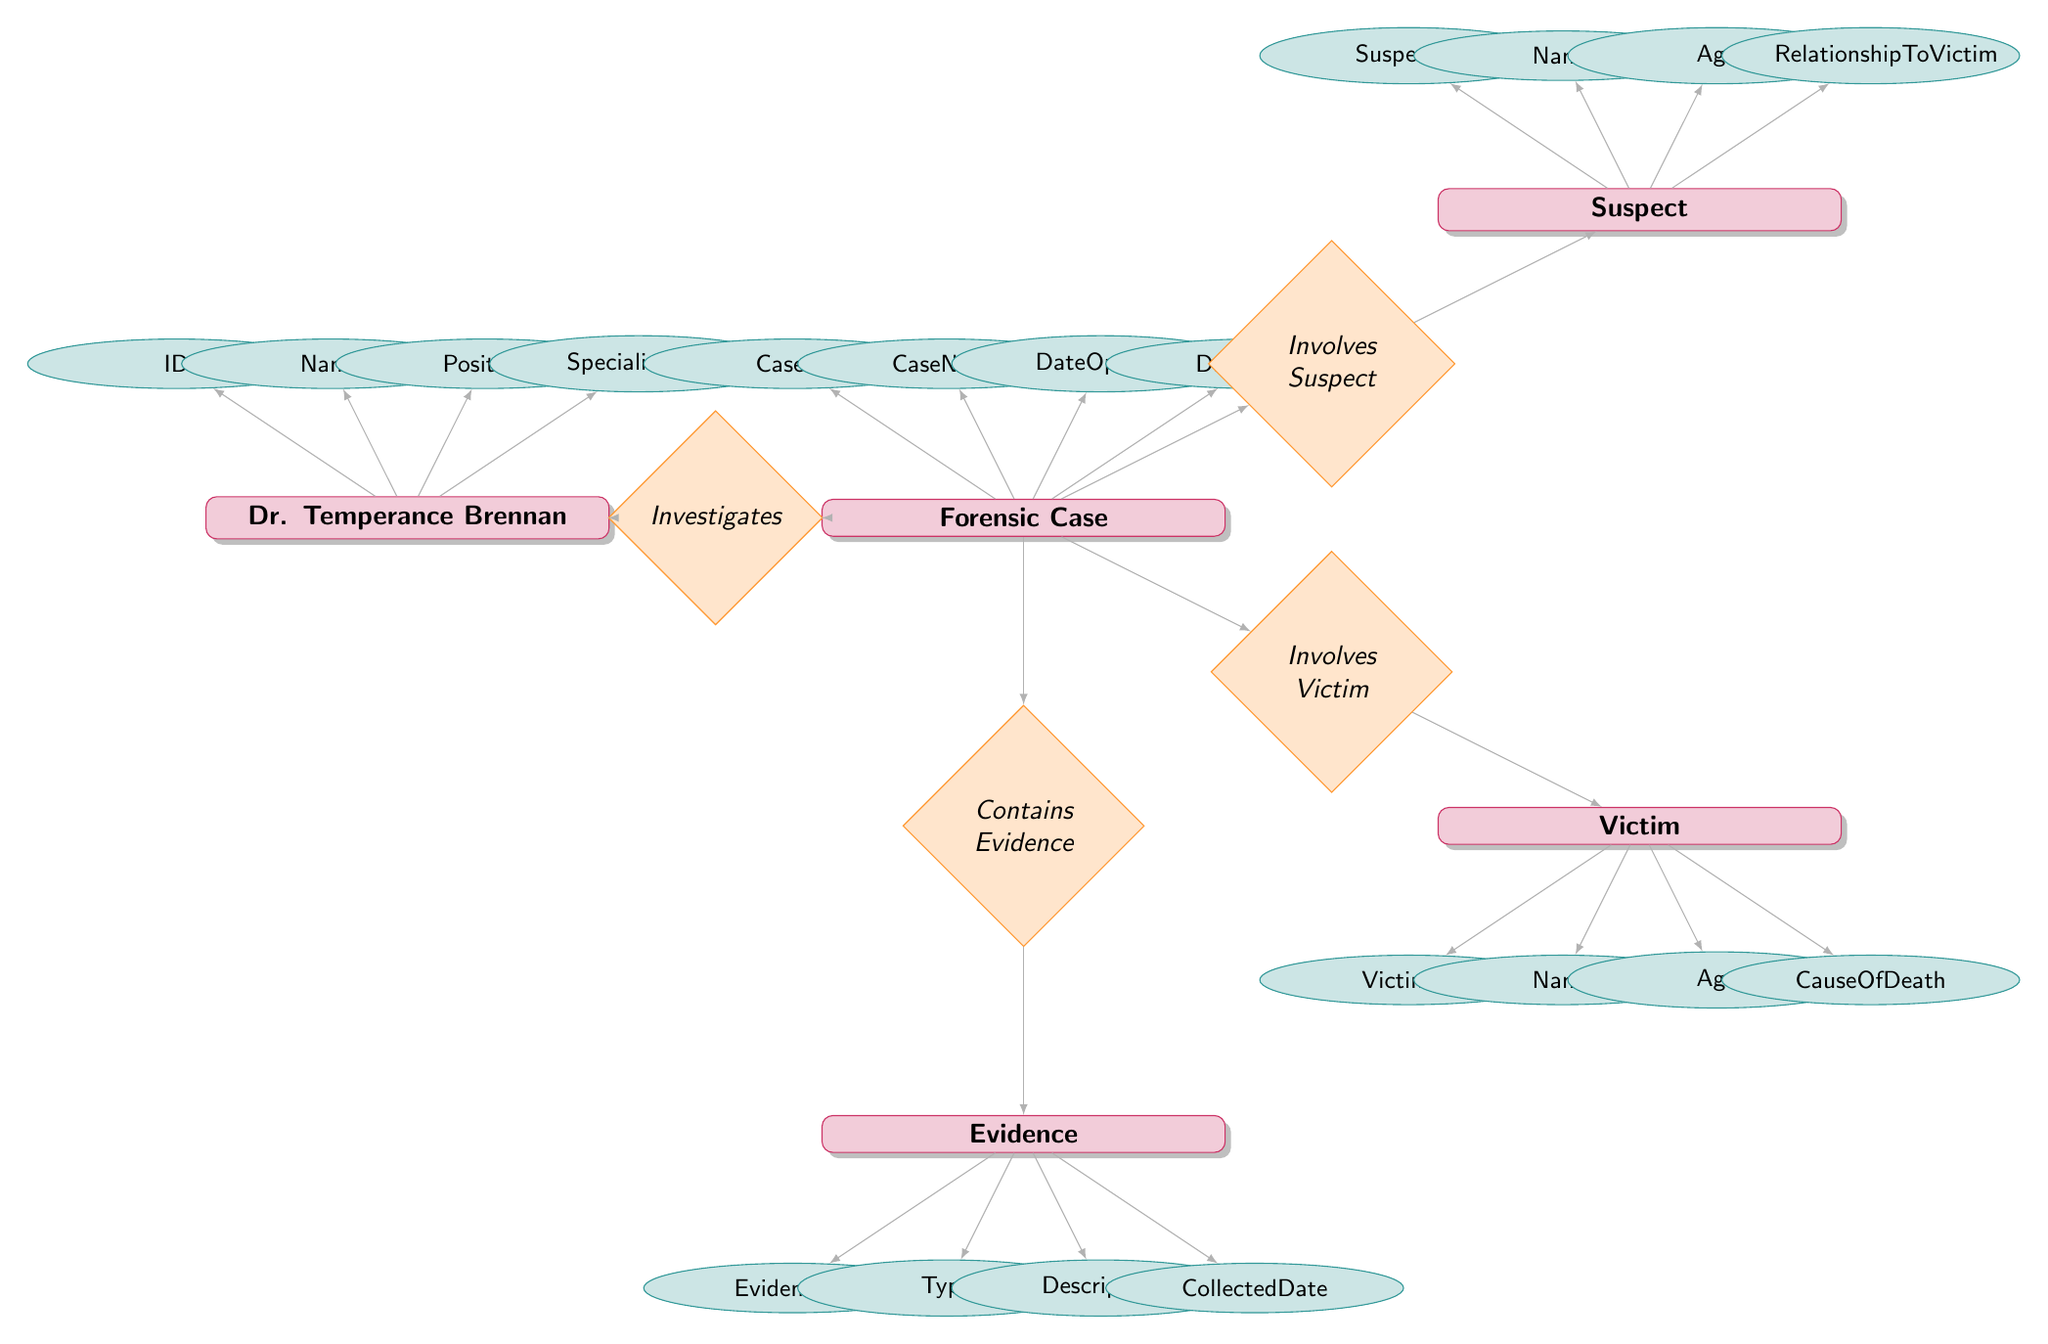What is the name of the main investigator in the diagram? The diagram includes an entity named "Dr. Temperance Brennan," who is identified as the main investigator in the forensic cases.
Answer: Dr. Temperance Brennan How many attributes does the "Victim" entity have? The "Victim" entity has four attributes: VictimID, Name, Age, and CauseOfDeath, as indicated in the diagram.
Answer: 4 What is the relationship name between "Forensic Case" and "Victim"? The relationship connecting "Forensic Case" and "Victim" is called "Involves Victim," as shown in the diagram.
Answer: Involves Victim Which entity collects evidence linked to forensic cases? The "Evidence" entity is connected through the relationship "Contains Evidence," indicating it collects evidence related to forensic cases.
Answer: Evidence Which entity does Dr. Temperance Brennan investigate? The relationship named "Investigates" indicates that Dr. Temperance Brennan investigates the "Forensic Case" entity, as depicted in the diagram.
Answer: Forensic Case What is the type of relationship between "Forensic Case" and "Suspect"? The relationship linking "Forensic Case" and "Suspect" is termed "Involves Suspect," referring to the involvement of suspects in specific cases.
Answer: Involves Suspect How many total entities are present in the diagram? The diagram features five entities: Dr. Temperance Brennan, Forensic Case, Victim, Suspect, and Evidence, leading to a total count of five entities.
Answer: 5 What attributes are associated with the "Evidence" entity? The "Evidence" entity comprises four attributes: EvidenceID, Type, Description, and CollectedDate, as presented in the diagram.
Answer: EvidenceID, Type, Description, CollectedDate Which entity is directly linked to the "Contains Evidence" relationship? The "Contains Evidence" relationship directly links the "Forensic Case" entity to the "Evidence" entity, showing that forensic cases contain evidence.
Answer: Evidence 